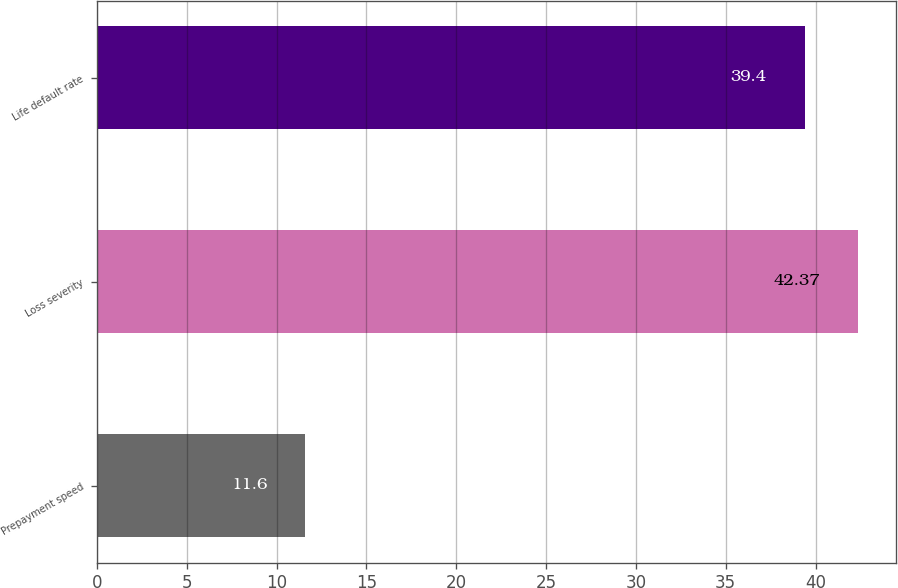<chart> <loc_0><loc_0><loc_500><loc_500><bar_chart><fcel>Prepayment speed<fcel>Loss severity<fcel>Life default rate<nl><fcel>11.6<fcel>42.37<fcel>39.4<nl></chart> 